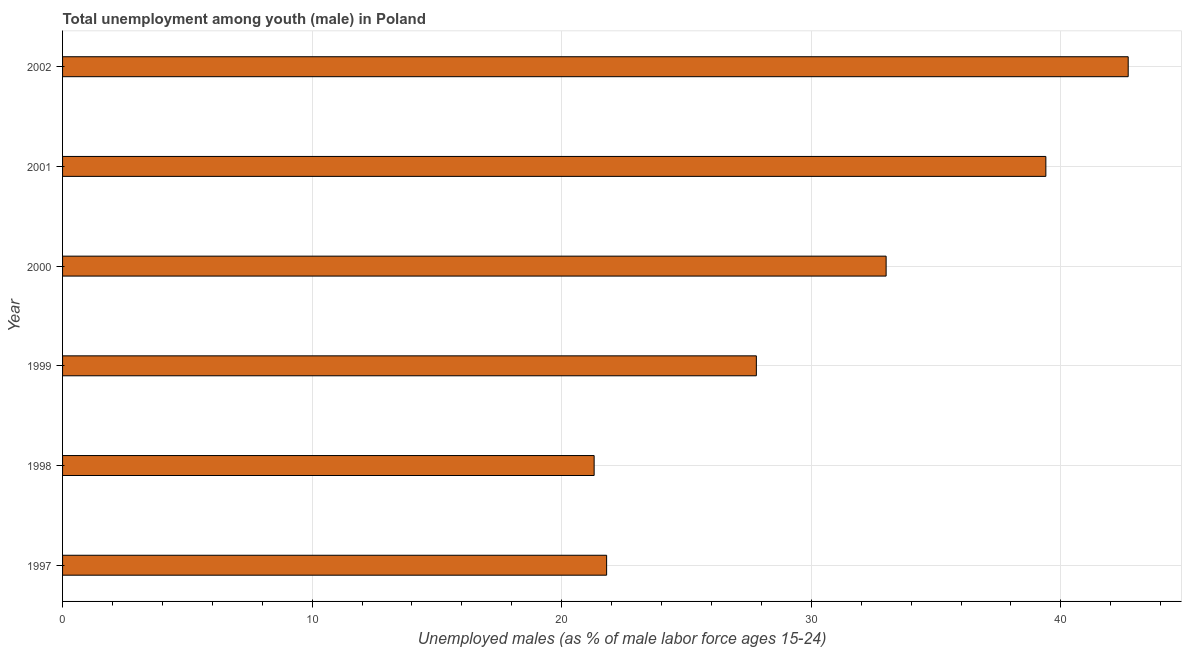Does the graph contain grids?
Provide a short and direct response. Yes. What is the title of the graph?
Offer a very short reply. Total unemployment among youth (male) in Poland. What is the label or title of the X-axis?
Your response must be concise. Unemployed males (as % of male labor force ages 15-24). What is the unemployed male youth population in 1997?
Offer a very short reply. 21.8. Across all years, what is the maximum unemployed male youth population?
Provide a short and direct response. 42.7. Across all years, what is the minimum unemployed male youth population?
Provide a succinct answer. 21.3. In which year was the unemployed male youth population maximum?
Offer a terse response. 2002. What is the sum of the unemployed male youth population?
Give a very brief answer. 186. What is the difference between the unemployed male youth population in 1997 and 1998?
Your answer should be compact. 0.5. What is the median unemployed male youth population?
Keep it short and to the point. 30.4. What is the ratio of the unemployed male youth population in 1998 to that in 2002?
Your answer should be very brief. 0.5. Is the unemployed male youth population in 1997 less than that in 1998?
Offer a very short reply. No. What is the difference between the highest and the second highest unemployed male youth population?
Provide a short and direct response. 3.3. Is the sum of the unemployed male youth population in 1997 and 1998 greater than the maximum unemployed male youth population across all years?
Your answer should be compact. Yes. What is the difference between the highest and the lowest unemployed male youth population?
Make the answer very short. 21.4. How many bars are there?
Your answer should be very brief. 6. How many years are there in the graph?
Ensure brevity in your answer.  6. What is the difference between two consecutive major ticks on the X-axis?
Give a very brief answer. 10. What is the Unemployed males (as % of male labor force ages 15-24) of 1997?
Provide a short and direct response. 21.8. What is the Unemployed males (as % of male labor force ages 15-24) in 1998?
Your answer should be compact. 21.3. What is the Unemployed males (as % of male labor force ages 15-24) of 1999?
Ensure brevity in your answer.  27.8. What is the Unemployed males (as % of male labor force ages 15-24) of 2001?
Your response must be concise. 39.4. What is the Unemployed males (as % of male labor force ages 15-24) in 2002?
Your answer should be very brief. 42.7. What is the difference between the Unemployed males (as % of male labor force ages 15-24) in 1997 and 1998?
Give a very brief answer. 0.5. What is the difference between the Unemployed males (as % of male labor force ages 15-24) in 1997 and 1999?
Your answer should be very brief. -6. What is the difference between the Unemployed males (as % of male labor force ages 15-24) in 1997 and 2000?
Offer a very short reply. -11.2. What is the difference between the Unemployed males (as % of male labor force ages 15-24) in 1997 and 2001?
Offer a terse response. -17.6. What is the difference between the Unemployed males (as % of male labor force ages 15-24) in 1997 and 2002?
Keep it short and to the point. -20.9. What is the difference between the Unemployed males (as % of male labor force ages 15-24) in 1998 and 1999?
Keep it short and to the point. -6.5. What is the difference between the Unemployed males (as % of male labor force ages 15-24) in 1998 and 2001?
Offer a very short reply. -18.1. What is the difference between the Unemployed males (as % of male labor force ages 15-24) in 1998 and 2002?
Make the answer very short. -21.4. What is the difference between the Unemployed males (as % of male labor force ages 15-24) in 1999 and 2002?
Provide a succinct answer. -14.9. What is the difference between the Unemployed males (as % of male labor force ages 15-24) in 2000 and 2001?
Provide a short and direct response. -6.4. What is the ratio of the Unemployed males (as % of male labor force ages 15-24) in 1997 to that in 1999?
Offer a very short reply. 0.78. What is the ratio of the Unemployed males (as % of male labor force ages 15-24) in 1997 to that in 2000?
Offer a very short reply. 0.66. What is the ratio of the Unemployed males (as % of male labor force ages 15-24) in 1997 to that in 2001?
Keep it short and to the point. 0.55. What is the ratio of the Unemployed males (as % of male labor force ages 15-24) in 1997 to that in 2002?
Your answer should be very brief. 0.51. What is the ratio of the Unemployed males (as % of male labor force ages 15-24) in 1998 to that in 1999?
Your answer should be compact. 0.77. What is the ratio of the Unemployed males (as % of male labor force ages 15-24) in 1998 to that in 2000?
Make the answer very short. 0.65. What is the ratio of the Unemployed males (as % of male labor force ages 15-24) in 1998 to that in 2001?
Your response must be concise. 0.54. What is the ratio of the Unemployed males (as % of male labor force ages 15-24) in 1998 to that in 2002?
Keep it short and to the point. 0.5. What is the ratio of the Unemployed males (as % of male labor force ages 15-24) in 1999 to that in 2000?
Keep it short and to the point. 0.84. What is the ratio of the Unemployed males (as % of male labor force ages 15-24) in 1999 to that in 2001?
Provide a short and direct response. 0.71. What is the ratio of the Unemployed males (as % of male labor force ages 15-24) in 1999 to that in 2002?
Offer a terse response. 0.65. What is the ratio of the Unemployed males (as % of male labor force ages 15-24) in 2000 to that in 2001?
Give a very brief answer. 0.84. What is the ratio of the Unemployed males (as % of male labor force ages 15-24) in 2000 to that in 2002?
Ensure brevity in your answer.  0.77. What is the ratio of the Unemployed males (as % of male labor force ages 15-24) in 2001 to that in 2002?
Keep it short and to the point. 0.92. 